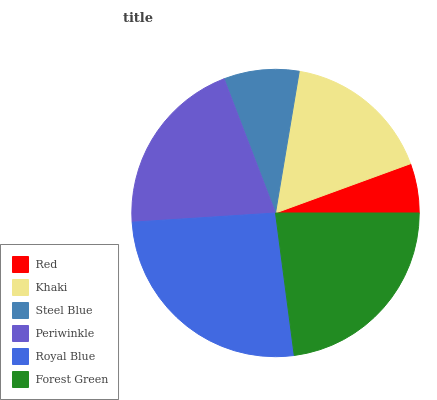Is Red the minimum?
Answer yes or no. Yes. Is Royal Blue the maximum?
Answer yes or no. Yes. Is Khaki the minimum?
Answer yes or no. No. Is Khaki the maximum?
Answer yes or no. No. Is Khaki greater than Red?
Answer yes or no. Yes. Is Red less than Khaki?
Answer yes or no. Yes. Is Red greater than Khaki?
Answer yes or no. No. Is Khaki less than Red?
Answer yes or no. No. Is Periwinkle the high median?
Answer yes or no. Yes. Is Khaki the low median?
Answer yes or no. Yes. Is Royal Blue the high median?
Answer yes or no. No. Is Red the low median?
Answer yes or no. No. 